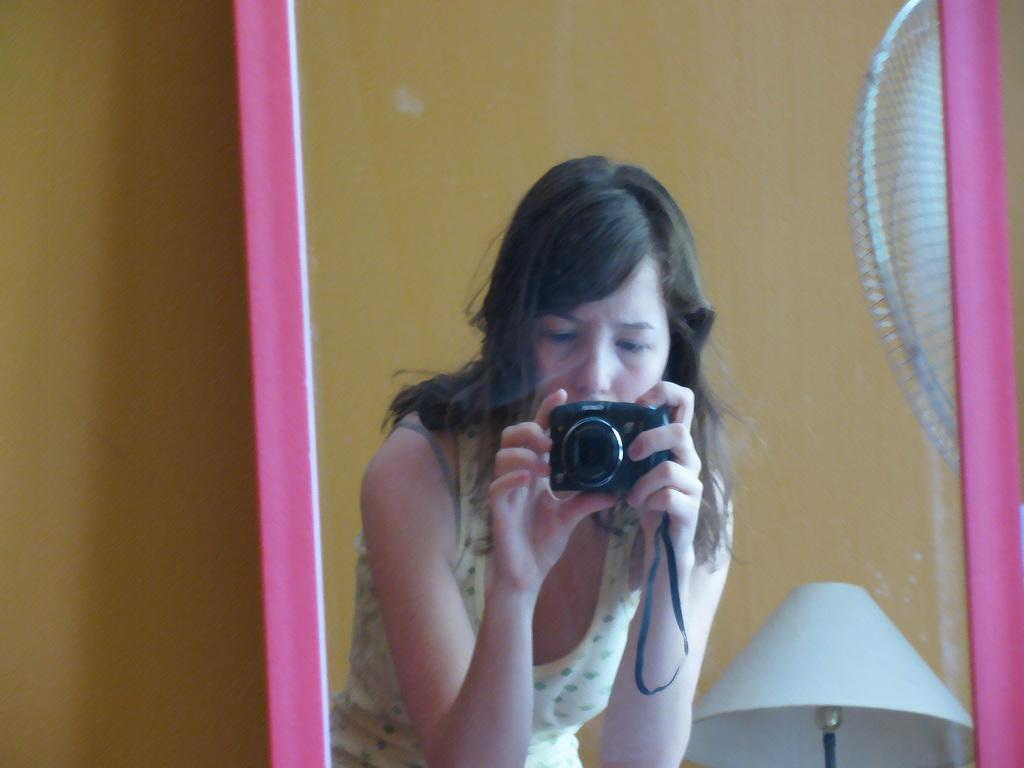What object in the image reflects its surroundings? There is a mirror in the image that reflects its surroundings. What can be seen in the mirror's reflection? The mirror reflects a lady holding a camera, a lamp, and part of a fan. What is visible in the background of the image? There is a wall in the background of the image. Where is the metal crowd gathered in the image? There is no metal crowd present in the image. Can you see a bird's nest in the image? There is no bird's nest visible in the image. 